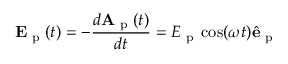<formula> <loc_0><loc_0><loc_500><loc_500>E _ { p } ( t ) = - \frac { d A _ { p } ( t ) } { d t } = E _ { p } \cos ( \omega t ) \hat { e } _ { p }</formula> 